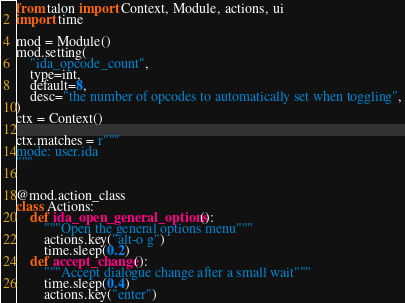<code> <loc_0><loc_0><loc_500><loc_500><_Python_>from talon import Context, Module, actions, ui
import time

mod = Module()
mod.setting(
    "ida_opcode_count",
    type=int,
    default=8,
    desc="the number of opcodes to automatically set when toggling",
)
ctx = Context()

ctx.matches = r"""
mode: user.ida
"""


@mod.action_class
class Actions:
    def ida_open_general_options():
        """Open the general options menu"""
        actions.key("alt-o g")
        time.sleep(0.2)
    def accept_change():
        """Accept dialogue change after a small wait"""
        time.sleep(0.4)
        actions.key("enter")
</code> 